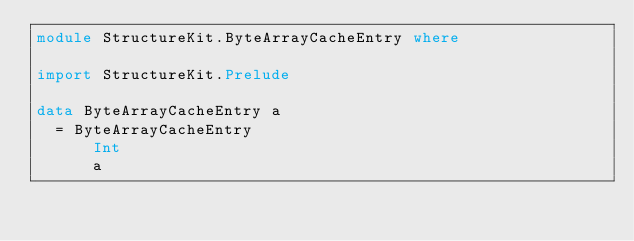Convert code to text. <code><loc_0><loc_0><loc_500><loc_500><_Haskell_>module StructureKit.ByteArrayCacheEntry where

import StructureKit.Prelude

data ByteArrayCacheEntry a
  = ByteArrayCacheEntry
      Int
      a
</code> 